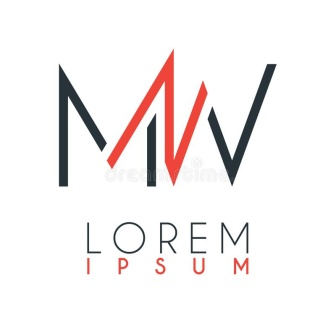How might this logo be used in a branding strategy? This logo could act as the cornerstone of a branding strategy by providing a consistent visual element that can be adapted across various materials. It could be used on business cards, website headers, marketing materials, and product packaging. The distinctive and adaptable design allows for instant recognition, and the cohesiveness of using the same color scheme and typographic style would reinforce brand identity across all platforms. 